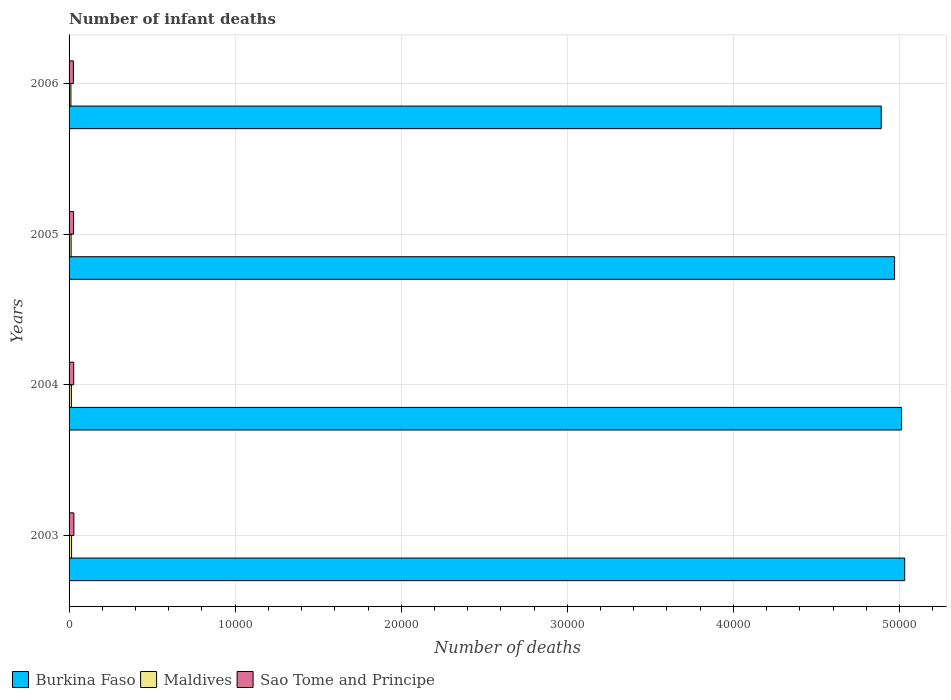How many groups of bars are there?
Give a very brief answer. 4. Are the number of bars on each tick of the Y-axis equal?
Provide a short and direct response. Yes. How many bars are there on the 1st tick from the top?
Ensure brevity in your answer.  3. How many bars are there on the 1st tick from the bottom?
Make the answer very short. 3. What is the label of the 1st group of bars from the top?
Your answer should be compact. 2006. What is the number of infant deaths in Burkina Faso in 2005?
Offer a terse response. 4.97e+04. Across all years, what is the maximum number of infant deaths in Maldives?
Provide a short and direct response. 151. Across all years, what is the minimum number of infant deaths in Burkina Faso?
Make the answer very short. 4.89e+04. In which year was the number of infant deaths in Maldives maximum?
Offer a terse response. 2003. What is the total number of infant deaths in Maldives in the graph?
Provide a short and direct response. 524. What is the difference between the number of infant deaths in Burkina Faso in 2003 and that in 2006?
Provide a short and direct response. 1414. What is the difference between the number of infant deaths in Sao Tome and Principe in 2006 and the number of infant deaths in Maldives in 2005?
Keep it short and to the point. 138. What is the average number of infant deaths in Burkina Faso per year?
Your response must be concise. 4.98e+04. In the year 2003, what is the difference between the number of infant deaths in Sao Tome and Principe and number of infant deaths in Burkina Faso?
Ensure brevity in your answer.  -5.00e+04. What is the ratio of the number of infant deaths in Burkina Faso in 2003 to that in 2006?
Give a very brief answer. 1.03. Is the number of infant deaths in Burkina Faso in 2003 less than that in 2004?
Offer a very short reply. No. Is the difference between the number of infant deaths in Sao Tome and Principe in 2004 and 2005 greater than the difference between the number of infant deaths in Burkina Faso in 2004 and 2005?
Give a very brief answer. No. What is the difference between the highest and the second highest number of infant deaths in Burkina Faso?
Your answer should be very brief. 190. What is the difference between the highest and the lowest number of infant deaths in Maldives?
Provide a succinct answer. 40. What does the 2nd bar from the top in 2005 represents?
Your response must be concise. Maldives. What does the 2nd bar from the bottom in 2003 represents?
Provide a short and direct response. Maldives. Are all the bars in the graph horizontal?
Make the answer very short. Yes. Where does the legend appear in the graph?
Make the answer very short. Bottom left. How many legend labels are there?
Provide a succinct answer. 3. How are the legend labels stacked?
Provide a succinct answer. Horizontal. What is the title of the graph?
Keep it short and to the point. Number of infant deaths. Does "Fragile and conflict affected situations" appear as one of the legend labels in the graph?
Make the answer very short. No. What is the label or title of the X-axis?
Keep it short and to the point. Number of deaths. What is the label or title of the Y-axis?
Provide a short and direct response. Years. What is the Number of deaths in Burkina Faso in 2003?
Make the answer very short. 5.03e+04. What is the Number of deaths of Maldives in 2003?
Make the answer very short. 151. What is the Number of deaths in Sao Tome and Principe in 2003?
Offer a very short reply. 289. What is the Number of deaths in Burkina Faso in 2004?
Offer a very short reply. 5.01e+04. What is the Number of deaths of Maldives in 2004?
Keep it short and to the point. 140. What is the Number of deaths of Sao Tome and Principe in 2004?
Your response must be concise. 280. What is the Number of deaths in Burkina Faso in 2005?
Make the answer very short. 4.97e+04. What is the Number of deaths in Maldives in 2005?
Your response must be concise. 122. What is the Number of deaths of Sao Tome and Principe in 2005?
Keep it short and to the point. 271. What is the Number of deaths in Burkina Faso in 2006?
Your response must be concise. 4.89e+04. What is the Number of deaths of Maldives in 2006?
Give a very brief answer. 111. What is the Number of deaths of Sao Tome and Principe in 2006?
Make the answer very short. 260. Across all years, what is the maximum Number of deaths of Burkina Faso?
Your response must be concise. 5.03e+04. Across all years, what is the maximum Number of deaths in Maldives?
Your response must be concise. 151. Across all years, what is the maximum Number of deaths in Sao Tome and Principe?
Ensure brevity in your answer.  289. Across all years, what is the minimum Number of deaths of Burkina Faso?
Make the answer very short. 4.89e+04. Across all years, what is the minimum Number of deaths in Maldives?
Ensure brevity in your answer.  111. Across all years, what is the minimum Number of deaths in Sao Tome and Principe?
Your answer should be compact. 260. What is the total Number of deaths in Burkina Faso in the graph?
Make the answer very short. 1.99e+05. What is the total Number of deaths in Maldives in the graph?
Offer a very short reply. 524. What is the total Number of deaths in Sao Tome and Principe in the graph?
Offer a terse response. 1100. What is the difference between the Number of deaths of Burkina Faso in 2003 and that in 2004?
Your response must be concise. 190. What is the difference between the Number of deaths in Burkina Faso in 2003 and that in 2005?
Keep it short and to the point. 610. What is the difference between the Number of deaths in Maldives in 2003 and that in 2005?
Make the answer very short. 29. What is the difference between the Number of deaths of Burkina Faso in 2003 and that in 2006?
Provide a succinct answer. 1414. What is the difference between the Number of deaths in Maldives in 2003 and that in 2006?
Give a very brief answer. 40. What is the difference between the Number of deaths of Burkina Faso in 2004 and that in 2005?
Your answer should be compact. 420. What is the difference between the Number of deaths of Burkina Faso in 2004 and that in 2006?
Provide a short and direct response. 1224. What is the difference between the Number of deaths of Maldives in 2004 and that in 2006?
Ensure brevity in your answer.  29. What is the difference between the Number of deaths in Sao Tome and Principe in 2004 and that in 2006?
Offer a very short reply. 20. What is the difference between the Number of deaths of Burkina Faso in 2005 and that in 2006?
Your answer should be compact. 804. What is the difference between the Number of deaths in Burkina Faso in 2003 and the Number of deaths in Maldives in 2004?
Ensure brevity in your answer.  5.02e+04. What is the difference between the Number of deaths of Burkina Faso in 2003 and the Number of deaths of Sao Tome and Principe in 2004?
Give a very brief answer. 5.00e+04. What is the difference between the Number of deaths in Maldives in 2003 and the Number of deaths in Sao Tome and Principe in 2004?
Your answer should be very brief. -129. What is the difference between the Number of deaths of Burkina Faso in 2003 and the Number of deaths of Maldives in 2005?
Your answer should be very brief. 5.02e+04. What is the difference between the Number of deaths of Burkina Faso in 2003 and the Number of deaths of Sao Tome and Principe in 2005?
Give a very brief answer. 5.00e+04. What is the difference between the Number of deaths in Maldives in 2003 and the Number of deaths in Sao Tome and Principe in 2005?
Your answer should be compact. -120. What is the difference between the Number of deaths in Burkina Faso in 2003 and the Number of deaths in Maldives in 2006?
Ensure brevity in your answer.  5.02e+04. What is the difference between the Number of deaths of Burkina Faso in 2003 and the Number of deaths of Sao Tome and Principe in 2006?
Keep it short and to the point. 5.01e+04. What is the difference between the Number of deaths of Maldives in 2003 and the Number of deaths of Sao Tome and Principe in 2006?
Offer a terse response. -109. What is the difference between the Number of deaths of Burkina Faso in 2004 and the Number of deaths of Maldives in 2005?
Your response must be concise. 5.00e+04. What is the difference between the Number of deaths of Burkina Faso in 2004 and the Number of deaths of Sao Tome and Principe in 2005?
Your answer should be very brief. 4.99e+04. What is the difference between the Number of deaths in Maldives in 2004 and the Number of deaths in Sao Tome and Principe in 2005?
Provide a short and direct response. -131. What is the difference between the Number of deaths in Burkina Faso in 2004 and the Number of deaths in Maldives in 2006?
Your answer should be very brief. 5.00e+04. What is the difference between the Number of deaths in Burkina Faso in 2004 and the Number of deaths in Sao Tome and Principe in 2006?
Ensure brevity in your answer.  4.99e+04. What is the difference between the Number of deaths in Maldives in 2004 and the Number of deaths in Sao Tome and Principe in 2006?
Keep it short and to the point. -120. What is the difference between the Number of deaths in Burkina Faso in 2005 and the Number of deaths in Maldives in 2006?
Provide a short and direct response. 4.96e+04. What is the difference between the Number of deaths in Burkina Faso in 2005 and the Number of deaths in Sao Tome and Principe in 2006?
Your answer should be very brief. 4.94e+04. What is the difference between the Number of deaths in Maldives in 2005 and the Number of deaths in Sao Tome and Principe in 2006?
Your answer should be compact. -138. What is the average Number of deaths of Burkina Faso per year?
Your answer should be very brief. 4.98e+04. What is the average Number of deaths of Maldives per year?
Make the answer very short. 131. What is the average Number of deaths in Sao Tome and Principe per year?
Provide a short and direct response. 275. In the year 2003, what is the difference between the Number of deaths in Burkina Faso and Number of deaths in Maldives?
Offer a very short reply. 5.02e+04. In the year 2003, what is the difference between the Number of deaths in Burkina Faso and Number of deaths in Sao Tome and Principe?
Your answer should be very brief. 5.00e+04. In the year 2003, what is the difference between the Number of deaths in Maldives and Number of deaths in Sao Tome and Principe?
Your answer should be very brief. -138. In the year 2004, what is the difference between the Number of deaths of Burkina Faso and Number of deaths of Maldives?
Keep it short and to the point. 5.00e+04. In the year 2004, what is the difference between the Number of deaths in Burkina Faso and Number of deaths in Sao Tome and Principe?
Offer a very short reply. 4.98e+04. In the year 2004, what is the difference between the Number of deaths in Maldives and Number of deaths in Sao Tome and Principe?
Keep it short and to the point. -140. In the year 2005, what is the difference between the Number of deaths of Burkina Faso and Number of deaths of Maldives?
Provide a succinct answer. 4.96e+04. In the year 2005, what is the difference between the Number of deaths in Burkina Faso and Number of deaths in Sao Tome and Principe?
Offer a terse response. 4.94e+04. In the year 2005, what is the difference between the Number of deaths in Maldives and Number of deaths in Sao Tome and Principe?
Ensure brevity in your answer.  -149. In the year 2006, what is the difference between the Number of deaths of Burkina Faso and Number of deaths of Maldives?
Your response must be concise. 4.88e+04. In the year 2006, what is the difference between the Number of deaths in Burkina Faso and Number of deaths in Sao Tome and Principe?
Make the answer very short. 4.86e+04. In the year 2006, what is the difference between the Number of deaths in Maldives and Number of deaths in Sao Tome and Principe?
Keep it short and to the point. -149. What is the ratio of the Number of deaths in Burkina Faso in 2003 to that in 2004?
Provide a short and direct response. 1. What is the ratio of the Number of deaths of Maldives in 2003 to that in 2004?
Make the answer very short. 1.08. What is the ratio of the Number of deaths of Sao Tome and Principe in 2003 to that in 2004?
Give a very brief answer. 1.03. What is the ratio of the Number of deaths in Burkina Faso in 2003 to that in 2005?
Offer a terse response. 1.01. What is the ratio of the Number of deaths in Maldives in 2003 to that in 2005?
Keep it short and to the point. 1.24. What is the ratio of the Number of deaths of Sao Tome and Principe in 2003 to that in 2005?
Offer a very short reply. 1.07. What is the ratio of the Number of deaths of Burkina Faso in 2003 to that in 2006?
Keep it short and to the point. 1.03. What is the ratio of the Number of deaths in Maldives in 2003 to that in 2006?
Your response must be concise. 1.36. What is the ratio of the Number of deaths in Sao Tome and Principe in 2003 to that in 2006?
Provide a short and direct response. 1.11. What is the ratio of the Number of deaths of Burkina Faso in 2004 to that in 2005?
Give a very brief answer. 1.01. What is the ratio of the Number of deaths of Maldives in 2004 to that in 2005?
Provide a short and direct response. 1.15. What is the ratio of the Number of deaths in Sao Tome and Principe in 2004 to that in 2005?
Provide a short and direct response. 1.03. What is the ratio of the Number of deaths in Maldives in 2004 to that in 2006?
Give a very brief answer. 1.26. What is the ratio of the Number of deaths of Burkina Faso in 2005 to that in 2006?
Provide a short and direct response. 1.02. What is the ratio of the Number of deaths of Maldives in 2005 to that in 2006?
Keep it short and to the point. 1.1. What is the ratio of the Number of deaths of Sao Tome and Principe in 2005 to that in 2006?
Give a very brief answer. 1.04. What is the difference between the highest and the second highest Number of deaths of Burkina Faso?
Offer a very short reply. 190. What is the difference between the highest and the second highest Number of deaths in Maldives?
Give a very brief answer. 11. What is the difference between the highest and the lowest Number of deaths in Burkina Faso?
Ensure brevity in your answer.  1414. What is the difference between the highest and the lowest Number of deaths in Maldives?
Provide a short and direct response. 40. 